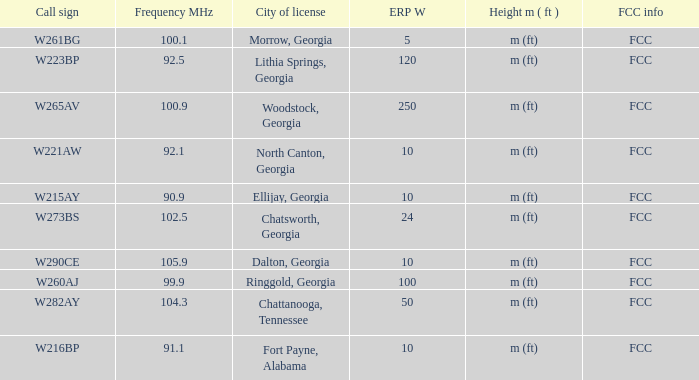How many mhz frequencies can be found in woodstock, georgia? 100.9. 